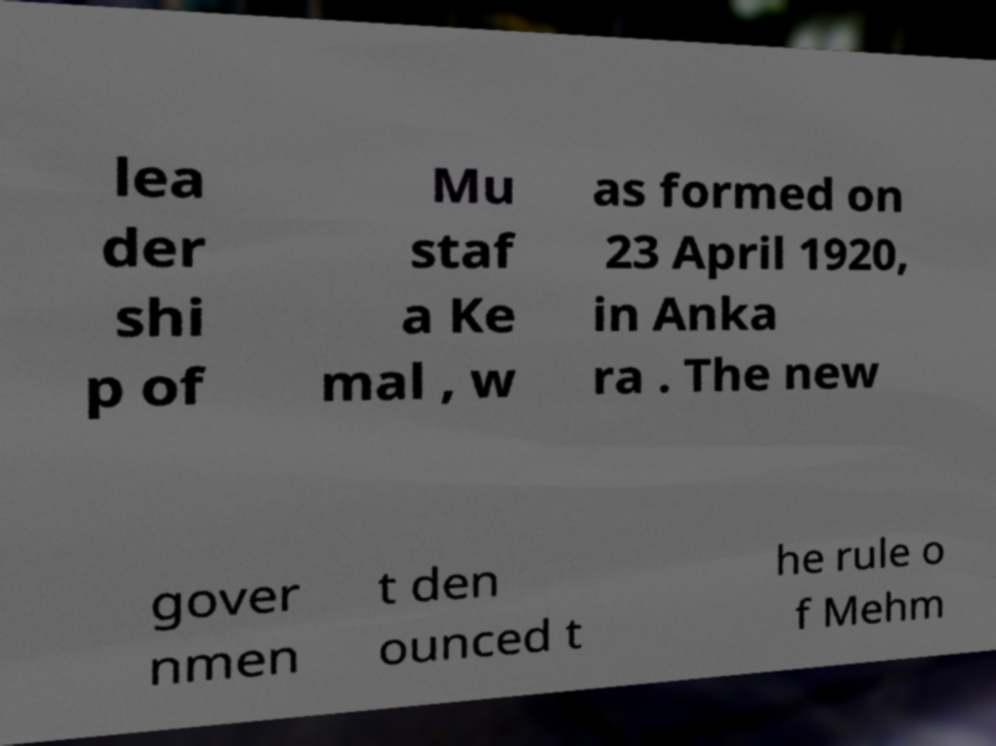Please read and relay the text visible in this image. What does it say? lea der shi p of Mu staf a Ke mal , w as formed on 23 April 1920, in Anka ra . The new gover nmen t den ounced t he rule o f Mehm 